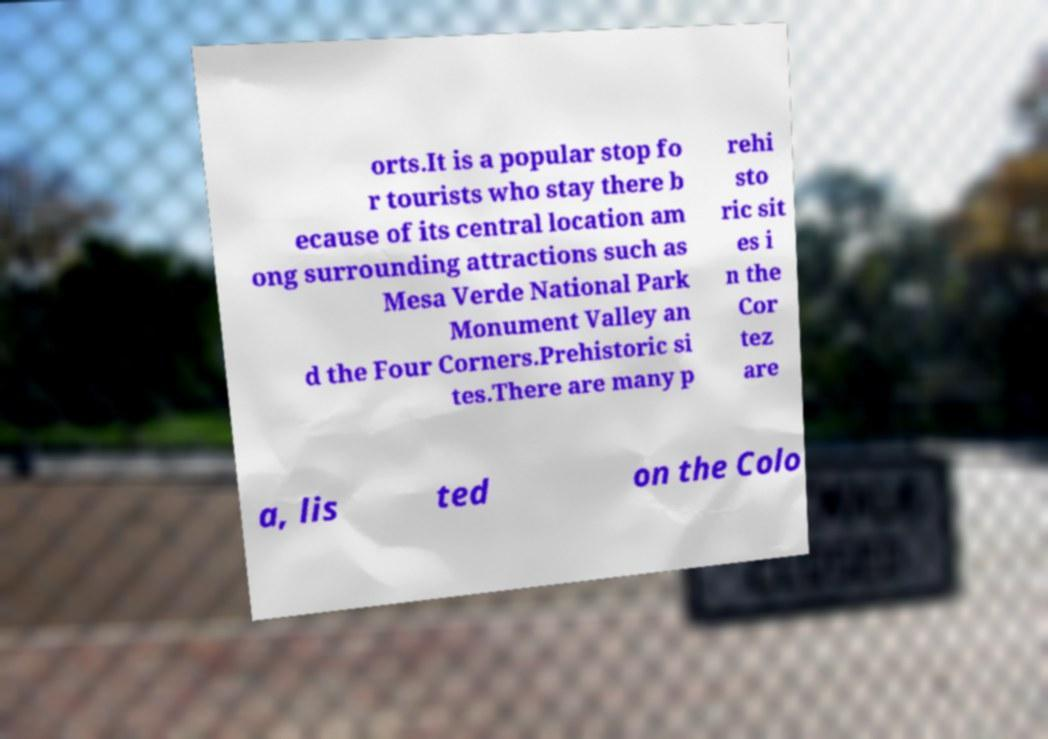Please identify and transcribe the text found in this image. orts.It is a popular stop fo r tourists who stay there b ecause of its central location am ong surrounding attractions such as Mesa Verde National Park Monument Valley an d the Four Corners.Prehistoric si tes.There are many p rehi sto ric sit es i n the Cor tez are a, lis ted on the Colo 